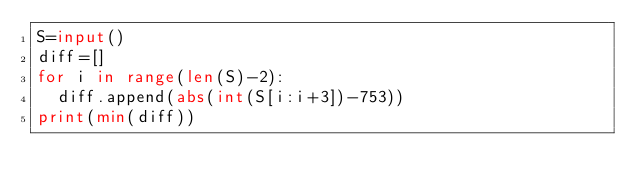<code> <loc_0><loc_0><loc_500><loc_500><_Python_>S=input()
diff=[]
for i in range(len(S)-2):
  diff.append(abs(int(S[i:i+3])-753))
print(min(diff))</code> 